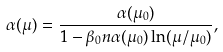<formula> <loc_0><loc_0><loc_500><loc_500>\alpha ( \mu ) = \frac { \alpha ( \mu _ { 0 } ) } { 1 - \beta _ { 0 } n \alpha ( \mu _ { 0 } ) \ln ( \mu / \mu _ { 0 } ) } ,</formula> 